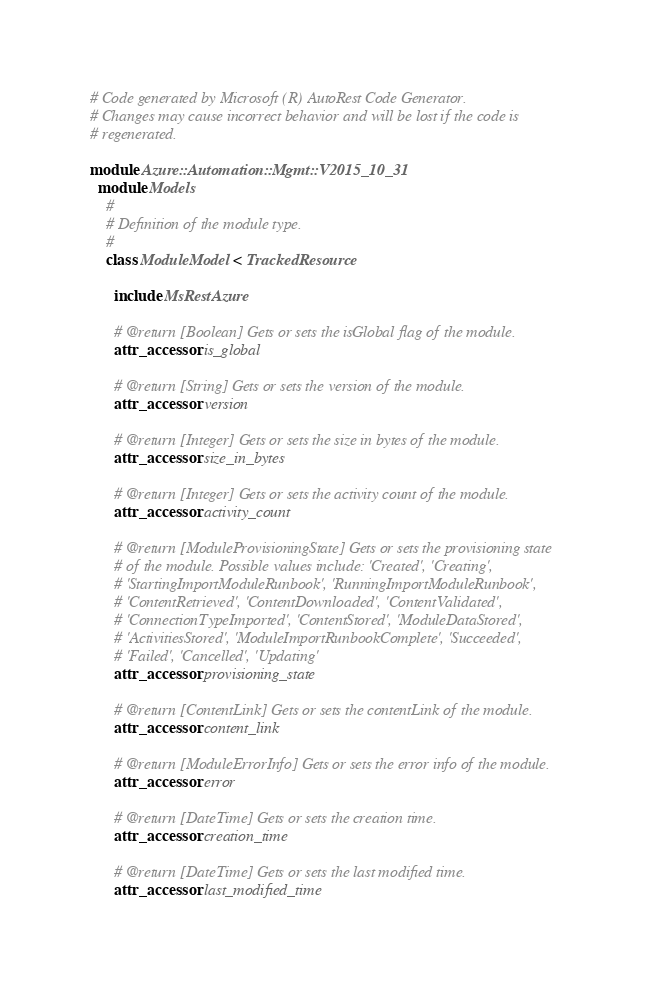Convert code to text. <code><loc_0><loc_0><loc_500><loc_500><_Ruby_># Code generated by Microsoft (R) AutoRest Code Generator.
# Changes may cause incorrect behavior and will be lost if the code is
# regenerated.

module Azure::Automation::Mgmt::V2015_10_31
  module Models
    #
    # Definition of the module type.
    #
    class ModuleModel < TrackedResource

      include MsRestAzure

      # @return [Boolean] Gets or sets the isGlobal flag of the module.
      attr_accessor :is_global

      # @return [String] Gets or sets the version of the module.
      attr_accessor :version

      # @return [Integer] Gets or sets the size in bytes of the module.
      attr_accessor :size_in_bytes

      # @return [Integer] Gets or sets the activity count of the module.
      attr_accessor :activity_count

      # @return [ModuleProvisioningState] Gets or sets the provisioning state
      # of the module. Possible values include: 'Created', 'Creating',
      # 'StartingImportModuleRunbook', 'RunningImportModuleRunbook',
      # 'ContentRetrieved', 'ContentDownloaded', 'ContentValidated',
      # 'ConnectionTypeImported', 'ContentStored', 'ModuleDataStored',
      # 'ActivitiesStored', 'ModuleImportRunbookComplete', 'Succeeded',
      # 'Failed', 'Cancelled', 'Updating'
      attr_accessor :provisioning_state

      # @return [ContentLink] Gets or sets the contentLink of the module.
      attr_accessor :content_link

      # @return [ModuleErrorInfo] Gets or sets the error info of the module.
      attr_accessor :error

      # @return [DateTime] Gets or sets the creation time.
      attr_accessor :creation_time

      # @return [DateTime] Gets or sets the last modified time.
      attr_accessor :last_modified_time
</code> 